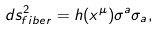Convert formula to latex. <formula><loc_0><loc_0><loc_500><loc_500>d s ^ { 2 } _ { f i b e r } = h ( x ^ { \mu } ) \sigma ^ { a } \sigma _ { a } ,</formula> 